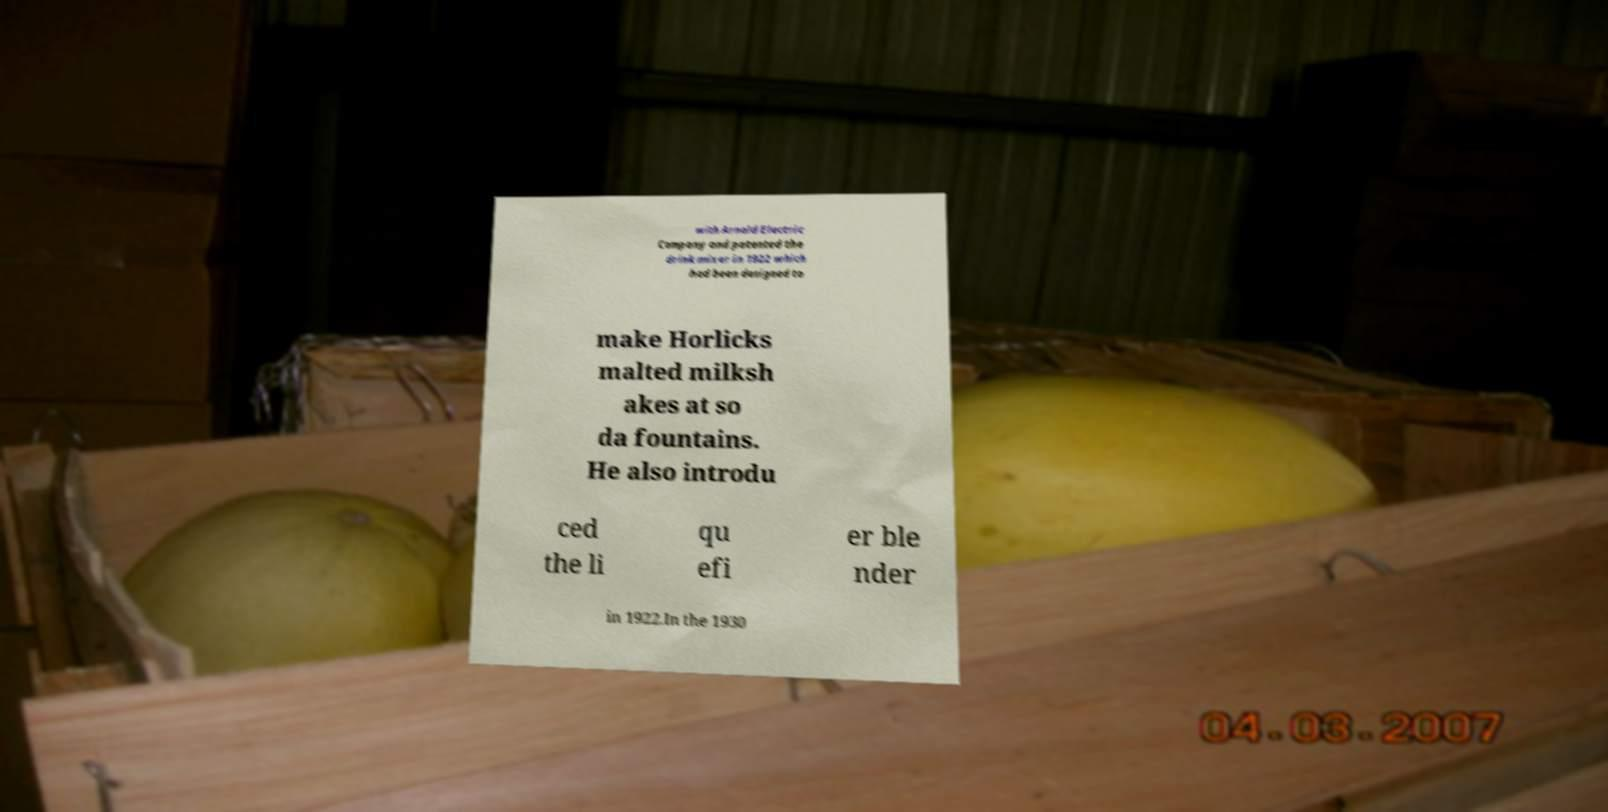For documentation purposes, I need the text within this image transcribed. Could you provide that? with Arnold Electric Company and patented the drink mixer in 1922 which had been designed to make Horlicks malted milksh akes at so da fountains. He also introdu ced the li qu efi er ble nder in 1922.In the 1930 